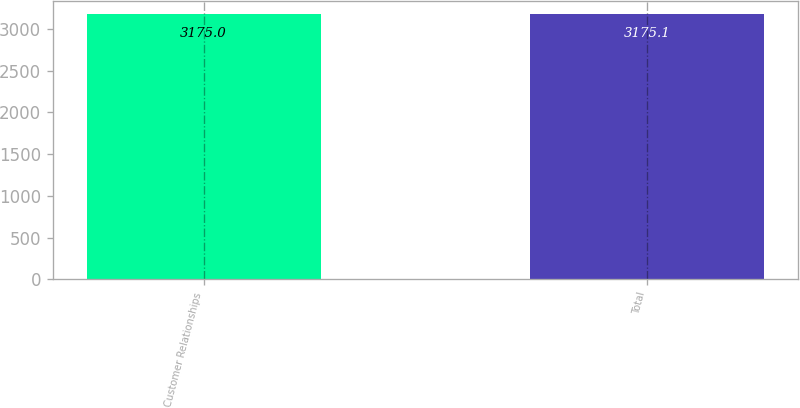<chart> <loc_0><loc_0><loc_500><loc_500><bar_chart><fcel>Customer Relationships<fcel>Total<nl><fcel>3175<fcel>3175.1<nl></chart> 